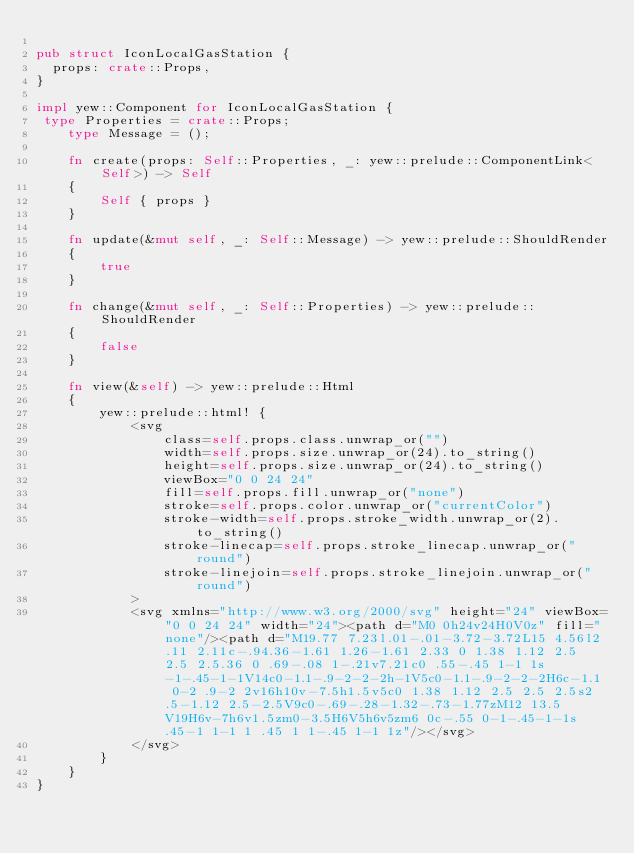Convert code to text. <code><loc_0><loc_0><loc_500><loc_500><_Rust_>
pub struct IconLocalGasStation {
  props: crate::Props,
}

impl yew::Component for IconLocalGasStation {
 type Properties = crate::Props;
    type Message = ();

    fn create(props: Self::Properties, _: yew::prelude::ComponentLink<Self>) -> Self
    {
        Self { props }
    }

    fn update(&mut self, _: Self::Message) -> yew::prelude::ShouldRender
    {
        true
    }

    fn change(&mut self, _: Self::Properties) -> yew::prelude::ShouldRender
    {
        false
    }

    fn view(&self) -> yew::prelude::Html
    {
        yew::prelude::html! {
            <svg
                class=self.props.class.unwrap_or("")
                width=self.props.size.unwrap_or(24).to_string()
                height=self.props.size.unwrap_or(24).to_string()
                viewBox="0 0 24 24"
                fill=self.props.fill.unwrap_or("none")
                stroke=self.props.color.unwrap_or("currentColor")
                stroke-width=self.props.stroke_width.unwrap_or(2).to_string()
                stroke-linecap=self.props.stroke_linecap.unwrap_or("round")
                stroke-linejoin=self.props.stroke_linejoin.unwrap_or("round")
            >
            <svg xmlns="http://www.w3.org/2000/svg" height="24" viewBox="0 0 24 24" width="24"><path d="M0 0h24v24H0V0z" fill="none"/><path d="M19.77 7.23l.01-.01-3.72-3.72L15 4.56l2.11 2.11c-.94.36-1.61 1.26-1.61 2.33 0 1.38 1.12 2.5 2.5 2.5.36 0 .69-.08 1-.21v7.21c0 .55-.45 1-1 1s-1-.45-1-1V14c0-1.1-.9-2-2-2h-1V5c0-1.1-.9-2-2-2H6c-1.1 0-2 .9-2 2v16h10v-7.5h1.5v5c0 1.38 1.12 2.5 2.5 2.5s2.5-1.12 2.5-2.5V9c0-.69-.28-1.32-.73-1.77zM12 13.5V19H6v-7h6v1.5zm0-3.5H6V5h6v5zm6 0c-.55 0-1-.45-1-1s.45-1 1-1 1 .45 1 1-.45 1-1 1z"/></svg>
            </svg>
        }
    }
}


</code> 